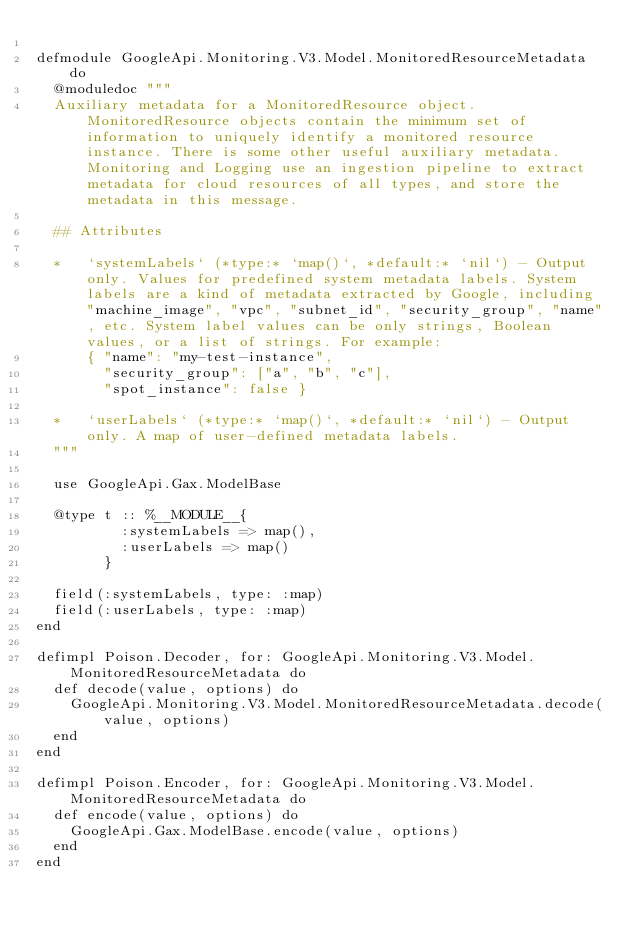<code> <loc_0><loc_0><loc_500><loc_500><_Elixir_>
defmodule GoogleApi.Monitoring.V3.Model.MonitoredResourceMetadata do
  @moduledoc """
  Auxiliary metadata for a MonitoredResource object. MonitoredResource objects contain the minimum set of information to uniquely identify a monitored resource instance. There is some other useful auxiliary metadata. Monitoring and Logging use an ingestion pipeline to extract metadata for cloud resources of all types, and store the metadata in this message.

  ## Attributes

  *   `systemLabels` (*type:* `map()`, *default:* `nil`) - Output only. Values for predefined system metadata labels. System labels are a kind of metadata extracted by Google, including "machine_image", "vpc", "subnet_id", "security_group", "name", etc. System label values can be only strings, Boolean values, or a list of strings. For example:
      { "name": "my-test-instance",
        "security_group": ["a", "b", "c"],
        "spot_instance": false }

  *   `userLabels` (*type:* `map()`, *default:* `nil`) - Output only. A map of user-defined metadata labels.
  """

  use GoogleApi.Gax.ModelBase

  @type t :: %__MODULE__{
          :systemLabels => map(),
          :userLabels => map()
        }

  field(:systemLabels, type: :map)
  field(:userLabels, type: :map)
end

defimpl Poison.Decoder, for: GoogleApi.Monitoring.V3.Model.MonitoredResourceMetadata do
  def decode(value, options) do
    GoogleApi.Monitoring.V3.Model.MonitoredResourceMetadata.decode(value, options)
  end
end

defimpl Poison.Encoder, for: GoogleApi.Monitoring.V3.Model.MonitoredResourceMetadata do
  def encode(value, options) do
    GoogleApi.Gax.ModelBase.encode(value, options)
  end
end
</code> 